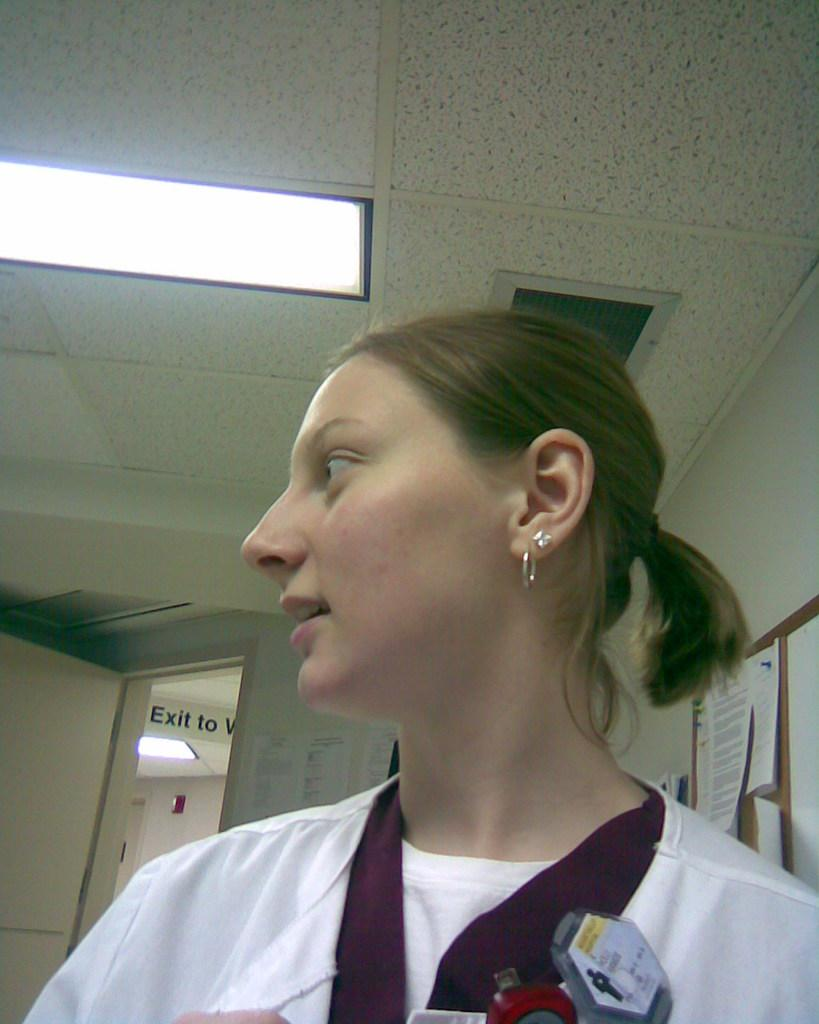Who is the main subject in the image? There is a girl in the image. What is the girl wearing? The girl is wearing a white top. In which direction is the girl looking? The girl is looking to the left. What can be seen in the background of the image? There is a notice board in the background. What is on the notice board? The notice board has many papers stuck on it. What type of needle is the girl using to sew a plastic bag in the image? There is no needle or plastic bag present in the image; the girl is simply looking to the left. Is the carpenter in the image working on a wooden project? There is no carpenter or wooden project present in the image; the main subject is a girl wearing a white top. 